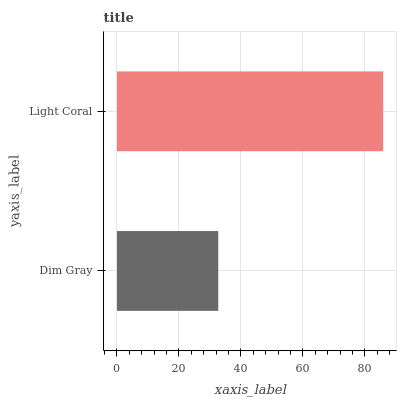Is Dim Gray the minimum?
Answer yes or no. Yes. Is Light Coral the maximum?
Answer yes or no. Yes. Is Light Coral the minimum?
Answer yes or no. No. Is Light Coral greater than Dim Gray?
Answer yes or no. Yes. Is Dim Gray less than Light Coral?
Answer yes or no. Yes. Is Dim Gray greater than Light Coral?
Answer yes or no. No. Is Light Coral less than Dim Gray?
Answer yes or no. No. Is Light Coral the high median?
Answer yes or no. Yes. Is Dim Gray the low median?
Answer yes or no. Yes. Is Dim Gray the high median?
Answer yes or no. No. Is Light Coral the low median?
Answer yes or no. No. 